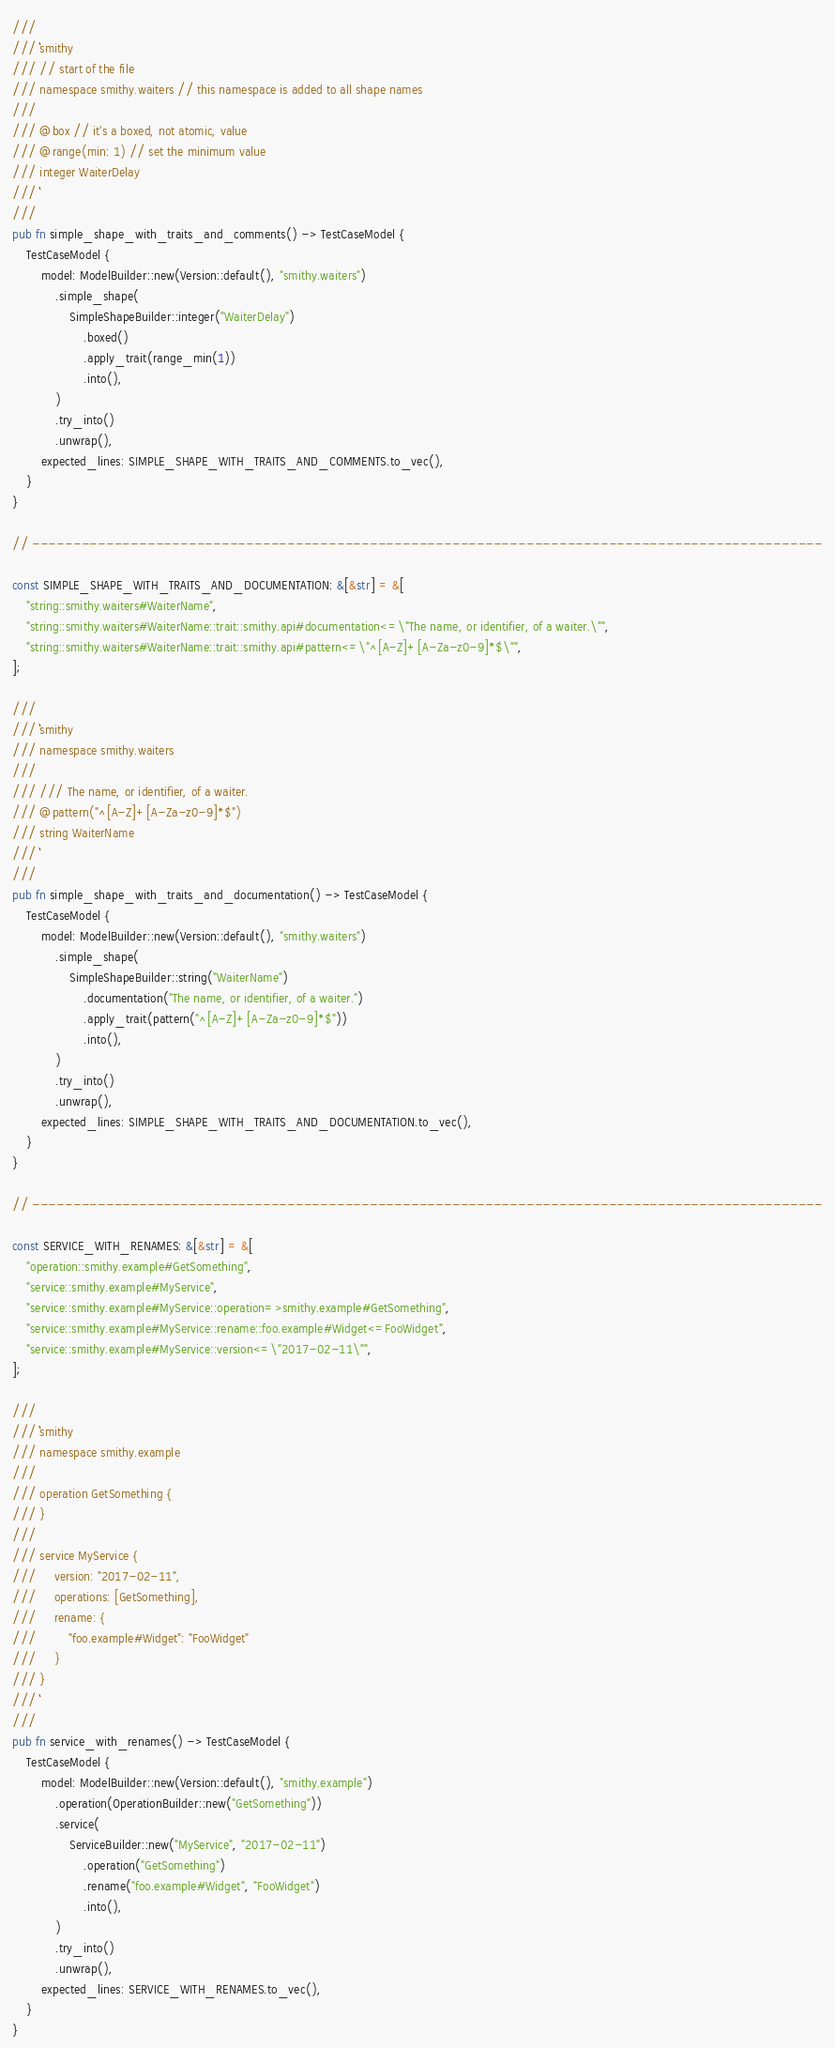Convert code to text. <code><loc_0><loc_0><loc_500><loc_500><_Rust_>
///
/// ```smithy
/// // start of the file
/// namespace smithy.waiters // this namespace is added to all shape names
///
/// @box // it's a boxed, not atomic, value
/// @range(min: 1) // set the minimum value
/// integer WaiterDelay
/// ```
///
pub fn simple_shape_with_traits_and_comments() -> TestCaseModel {
    TestCaseModel {
        model: ModelBuilder::new(Version::default(), "smithy.waiters")
            .simple_shape(
                SimpleShapeBuilder::integer("WaiterDelay")
                    .boxed()
                    .apply_trait(range_min(1))
                    .into(),
            )
            .try_into()
            .unwrap(),
        expected_lines: SIMPLE_SHAPE_WITH_TRAITS_AND_COMMENTS.to_vec(),
    }
}

// ------------------------------------------------------------------------------------------------

const SIMPLE_SHAPE_WITH_TRAITS_AND_DOCUMENTATION: &[&str] = &[
    "string::smithy.waiters#WaiterName",
    "string::smithy.waiters#WaiterName::trait::smithy.api#documentation<=\"The name, or identifier, of a waiter.\"",
    "string::smithy.waiters#WaiterName::trait::smithy.api#pattern<=\"^[A-Z]+[A-Za-z0-9]*$\"",
];

///
/// ```smithy
/// namespace smithy.waiters
///
/// /// The name, or identifier, of a waiter.
/// @pattern("^[A-Z]+[A-Za-z0-9]*$")
/// string WaiterName
/// ```
///
pub fn simple_shape_with_traits_and_documentation() -> TestCaseModel {
    TestCaseModel {
        model: ModelBuilder::new(Version::default(), "smithy.waiters")
            .simple_shape(
                SimpleShapeBuilder::string("WaiterName")
                    .documentation("The name, or identifier, of a waiter.")
                    .apply_trait(pattern("^[A-Z]+[A-Za-z0-9]*$"))
                    .into(),
            )
            .try_into()
            .unwrap(),
        expected_lines: SIMPLE_SHAPE_WITH_TRAITS_AND_DOCUMENTATION.to_vec(),
    }
}

// ------------------------------------------------------------------------------------------------

const SERVICE_WITH_RENAMES: &[&str] = &[
    "operation::smithy.example#GetSomething",
    "service::smithy.example#MyService",
    "service::smithy.example#MyService::operation=>smithy.example#GetSomething",
    "service::smithy.example#MyService::rename::foo.example#Widget<=FooWidget",
    "service::smithy.example#MyService::version<=\"2017-02-11\"",
];

///
/// ```smithy
/// namespace smithy.example
///
/// operation GetSomething {
/// }
///
/// service MyService {
///     version: "2017-02-11",
///     operations: [GetSomething],
///     rename: {
///         "foo.example#Widget": "FooWidget"
///     }
/// }
/// ```
///
pub fn service_with_renames() -> TestCaseModel {
    TestCaseModel {
        model: ModelBuilder::new(Version::default(), "smithy.example")
            .operation(OperationBuilder::new("GetSomething"))
            .service(
                ServiceBuilder::new("MyService", "2017-02-11")
                    .operation("GetSomething")
                    .rename("foo.example#Widget", "FooWidget")
                    .into(),
            )
            .try_into()
            .unwrap(),
        expected_lines: SERVICE_WITH_RENAMES.to_vec(),
    }
}
</code> 